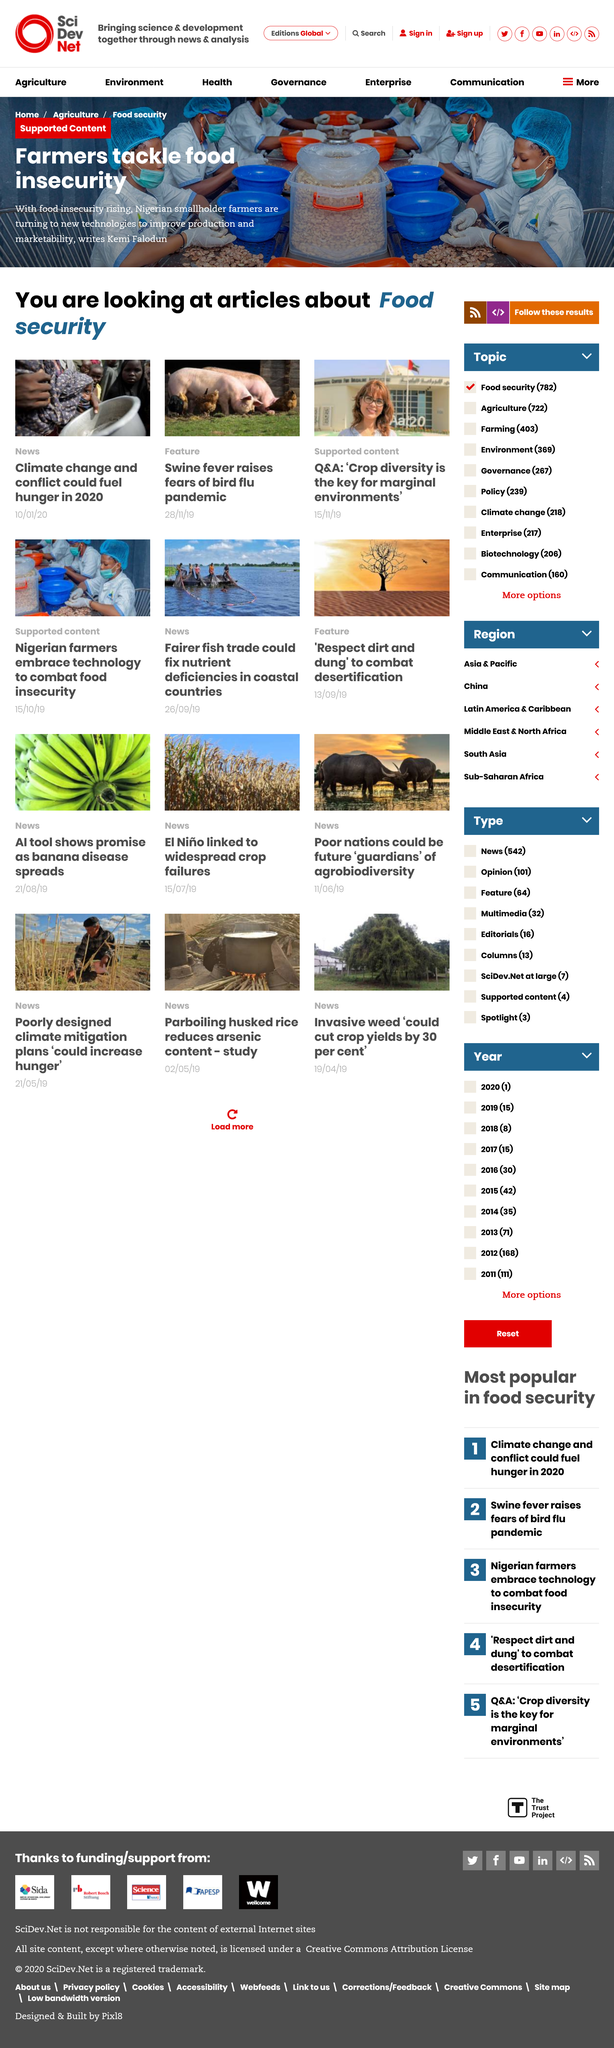Mention a couple of crucial points in this snapshot. The farmers who are working to address food insecurity can be found in Nigeria. Farmers are working tirelessly to address the critical issue of food insecurity. Climate change and conflict have the potential to fuel hunger in 2020. 